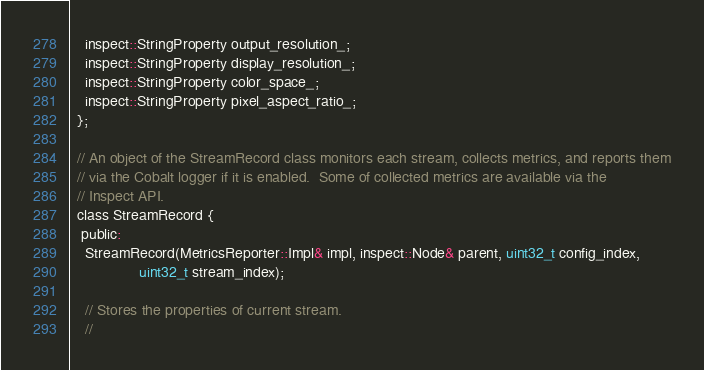Convert code to text. <code><loc_0><loc_0><loc_500><loc_500><_C_>    inspect::StringProperty output_resolution_;
    inspect::StringProperty display_resolution_;
    inspect::StringProperty color_space_;
    inspect::StringProperty pixel_aspect_ratio_;
  };

  // An object of the StreamRecord class monitors each stream, collects metrics, and reports them
  // via the Cobalt logger if it is enabled.  Some of collected metrics are available via the
  // Inspect API.
  class StreamRecord {
   public:
    StreamRecord(MetricsReporter::Impl& impl, inspect::Node& parent, uint32_t config_index,
                 uint32_t stream_index);

    // Stores the properties of current stream.
    //</code> 